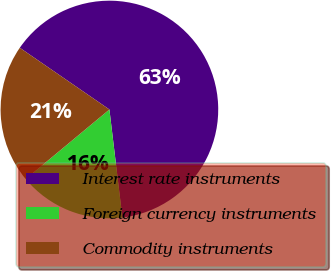Convert chart. <chart><loc_0><loc_0><loc_500><loc_500><pie_chart><fcel>Interest rate instruments<fcel>Foreign currency instruments<fcel>Commodity instruments<nl><fcel>63.49%<fcel>15.87%<fcel>20.63%<nl></chart> 